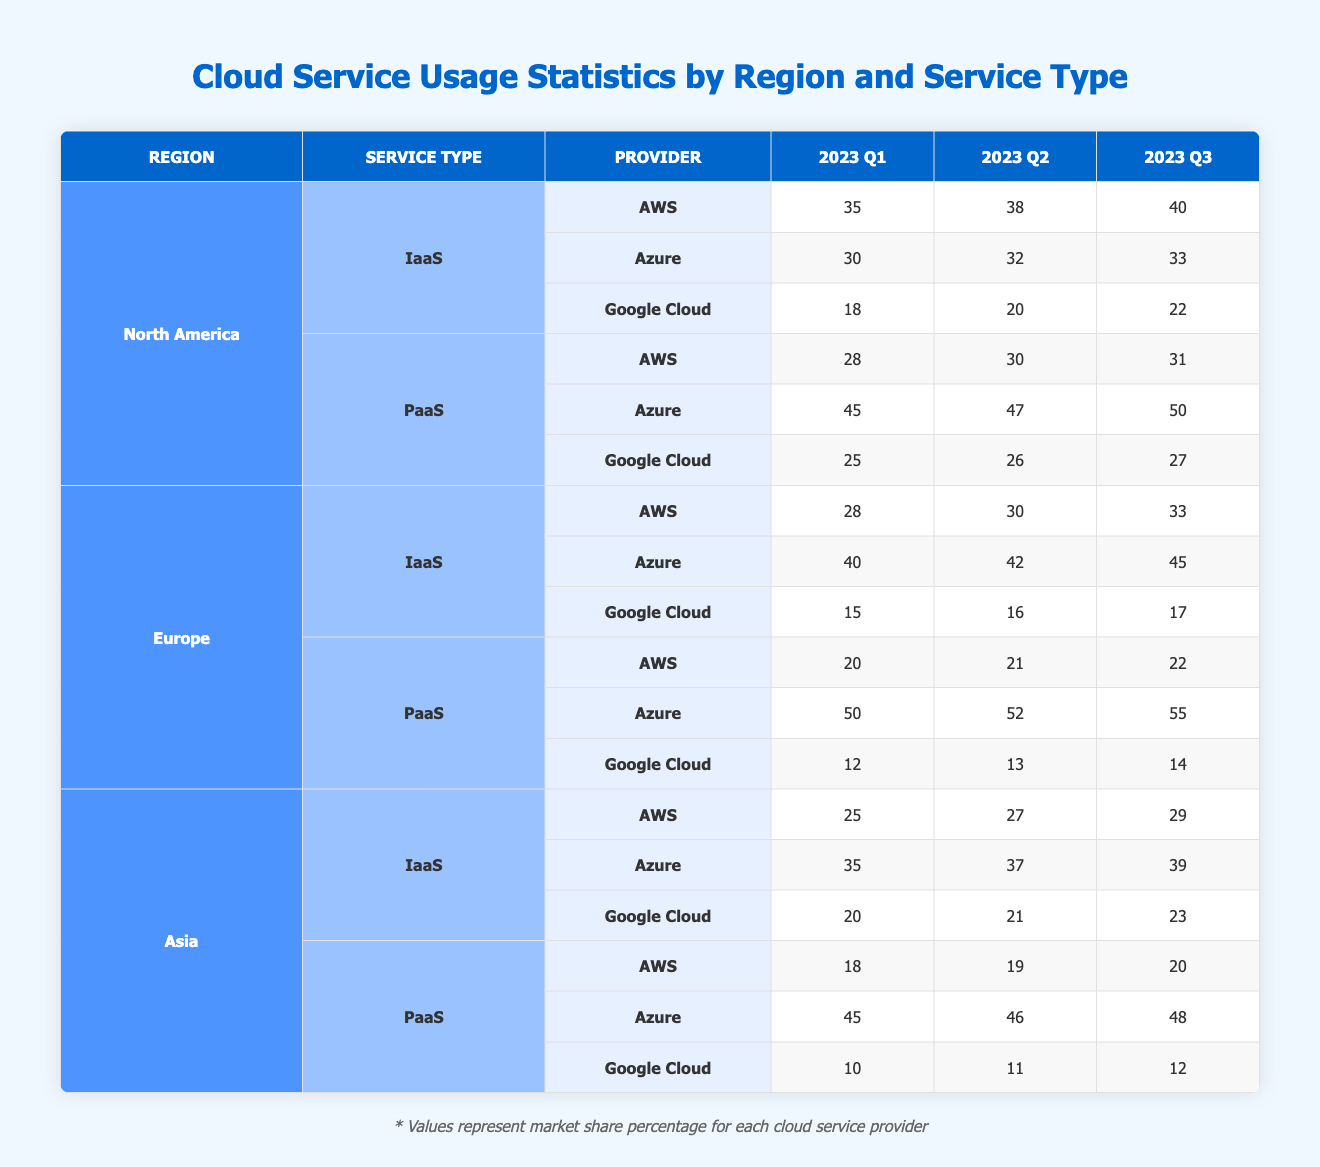What is the total IaaS usage percentage for AWS in North America for Q3 2023? From the table, the IaaS usage percentage for AWS in North America for Q3 2023 is 40. Therefore, the total is simply 40, as it’s the only value requested.
Answer: 40 What is the average PaaS usage percentage for Azure in Europe across all three quarters? The PaaS usage percentages for Azure in Europe are 50 (Q1), 52 (Q2), and 55 (Q3). Adding these values gives 50 + 52 + 55 = 157. Dividing by the number of quarters (3) results in an average of 157/3 = approximately 52.33.
Answer: 52.33 Did Google Cloud's IaaS usage in Asia increase over the three quarters in 2023? The usage percentages for Google Cloud's IaaS in Asia are 20 (Q1), 21 (Q2), and 23 (Q3). Since 20 < 21 < 23, it shows an increasing trend over the quarters.
Answer: Yes Which region had the highest PaaS usage for Google Cloud in Q2 2023? Looking at Q2 2023 PaaS usage for Google Cloud, we have North America with 26, Europe with 13, and Asia with 11. The highest percentage among these is 26 in North America.
Answer: North America What is the difference in IaaS usage percentage for Azure between North America and Europe in Q3 2023? For North America, Azure's IaaS percentage in Q3 2023 is 33, while in Europe, it’s 45. To find the difference: 45 - 33 = 12.
Answer: 12 Which cloud provider had the lowest overall IaaS usage in Europe during Q3 2023? The IaaS percentages in Europe for Q3 2023 are AWS at 33, Azure at 45, and Google Cloud at 17. The lowest usage is 17 for Google Cloud.
Answer: Google Cloud What is the total IaaS usage for Azure in North America for Q1 2023 and Q2 2023 combined? The IaaS usage for Azure in North America for Q1 2023 is 30, and for Q2 2023 is 32. Adding these gives 30 + 32 = 62.
Answer: 62 What is the median PaaS usage percentage for AWS across all regions in Q1 2023? The PaaS usage percentages for AWS across the three regions in Q1 2023 are 28 (North America), 20 (Europe), and 18 (Asia). Ordering these values gives 18, 20, and 28. The median, or middle value, is 20.
Answer: 20 